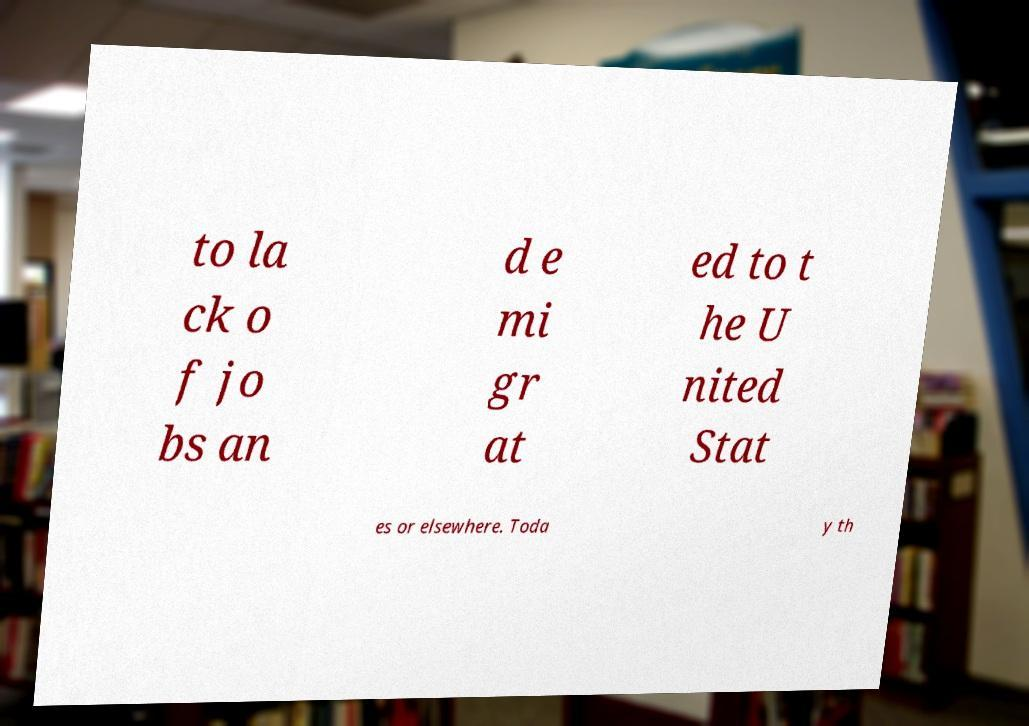Can you accurately transcribe the text from the provided image for me? to la ck o f jo bs an d e mi gr at ed to t he U nited Stat es or elsewhere. Toda y th 